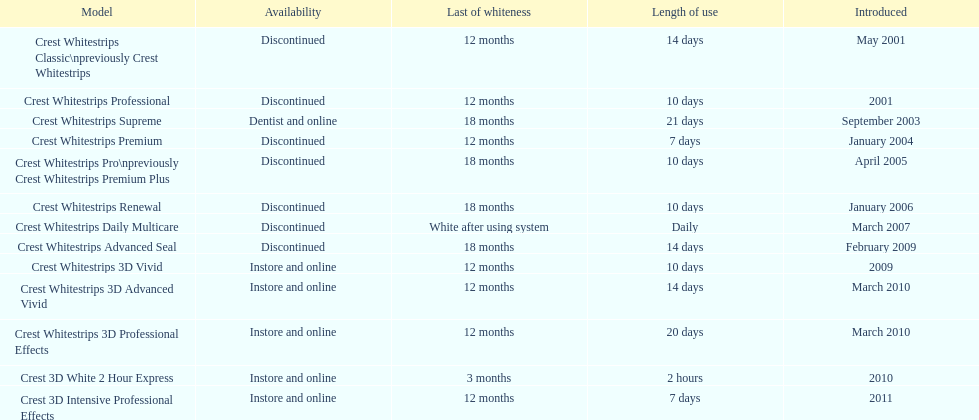Is each white strip discontinued? No. 